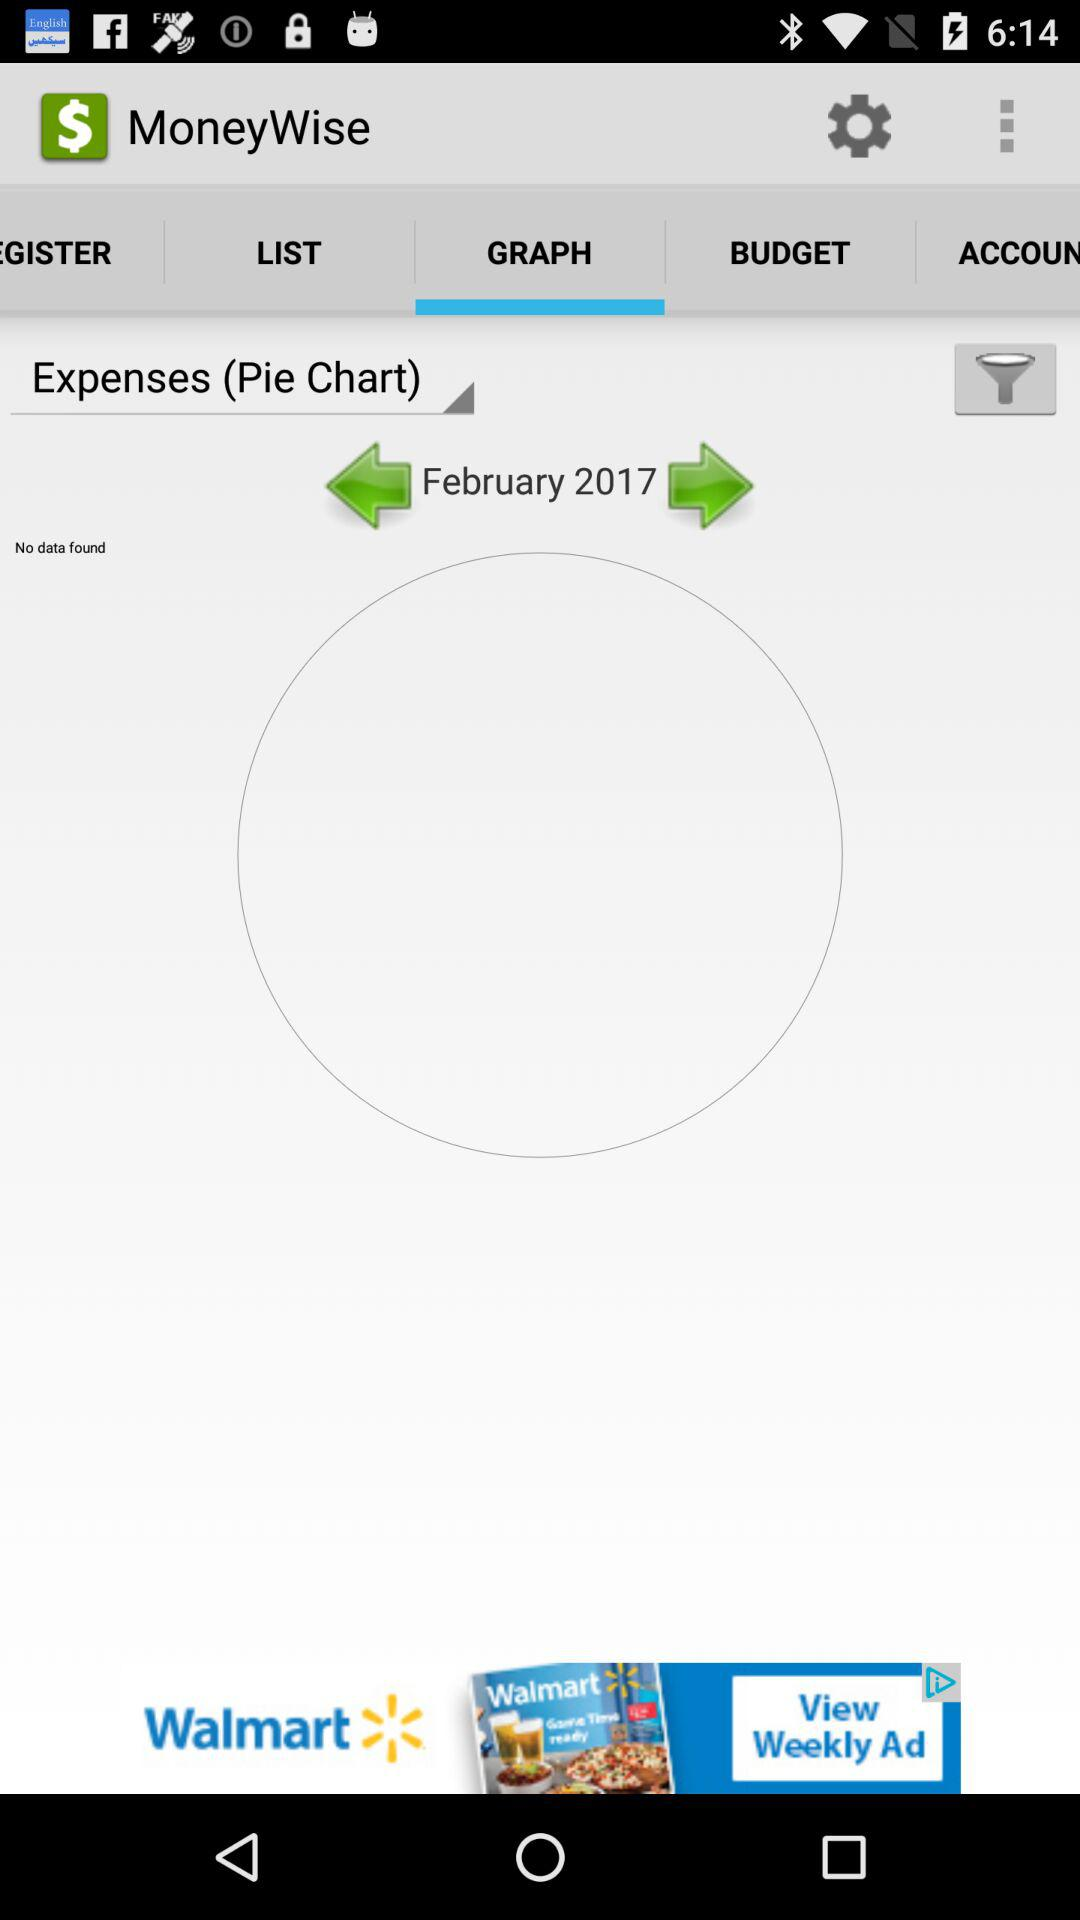What pie chart is selected? The selected pie chart is "Expenses". 